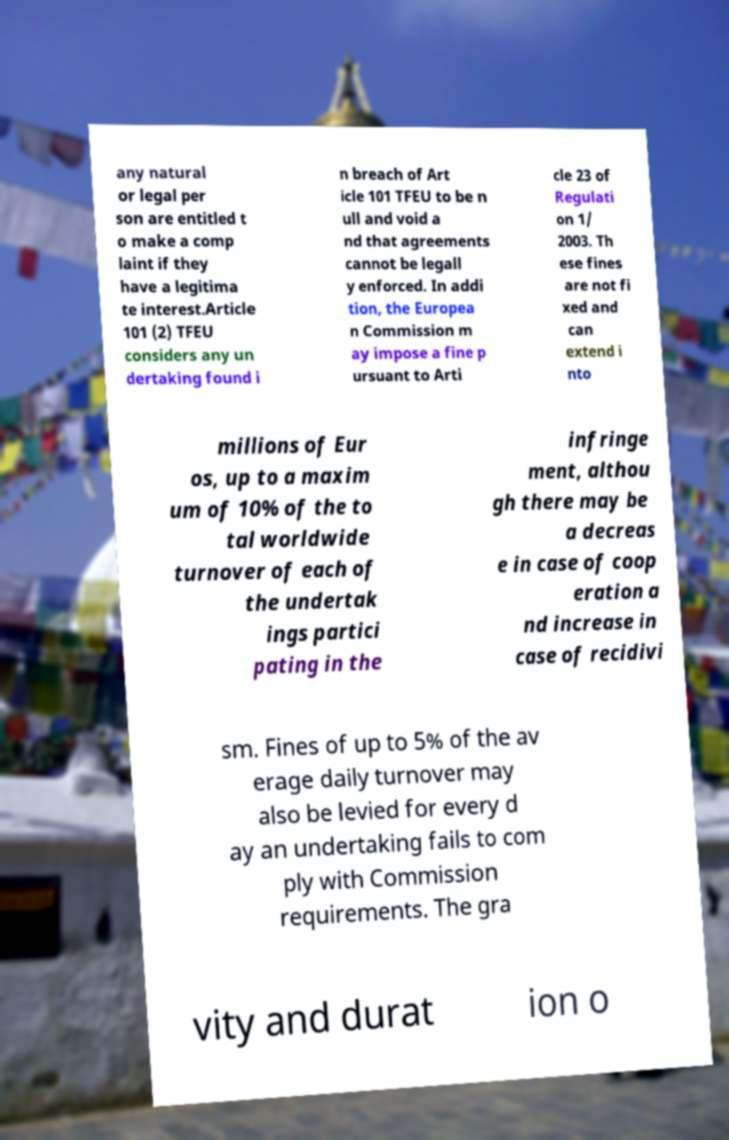Please identify and transcribe the text found in this image. any natural or legal per son are entitled t o make a comp laint if they have a legitima te interest.Article 101 (2) TFEU considers any un dertaking found i n breach of Art icle 101 TFEU to be n ull and void a nd that agreements cannot be legall y enforced. In addi tion, the Europea n Commission m ay impose a fine p ursuant to Arti cle 23 of Regulati on 1/ 2003. Th ese fines are not fi xed and can extend i nto millions of Eur os, up to a maxim um of 10% of the to tal worldwide turnover of each of the undertak ings partici pating in the infringe ment, althou gh there may be a decreas e in case of coop eration a nd increase in case of recidivi sm. Fines of up to 5% of the av erage daily turnover may also be levied for every d ay an undertaking fails to com ply with Commission requirements. The gra vity and durat ion o 